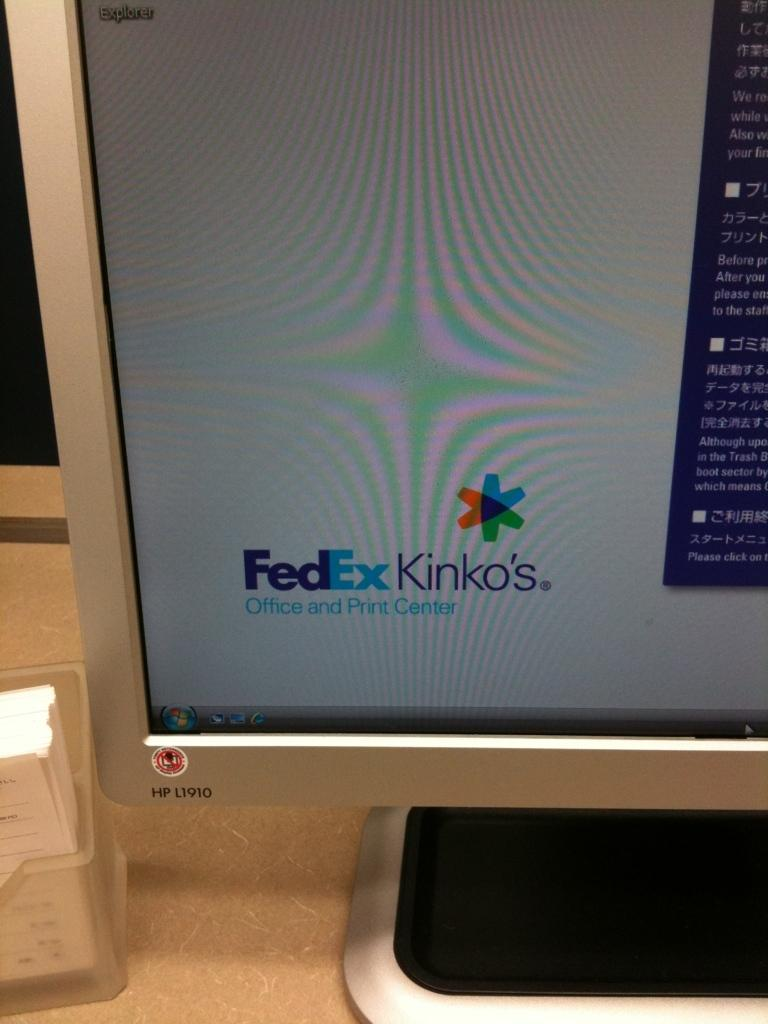<image>
Give a short and clear explanation of the subsequent image. a computer monitor that has Fedex Kinko's in the corner 